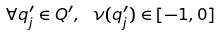Convert formula to latex. <formula><loc_0><loc_0><loc_500><loc_500>\forall q _ { j } ^ { \prime } \in Q ^ { \prime } , \ \nu ( q _ { j } ^ { \prime } ) \in [ - 1 , 0 ]</formula> 